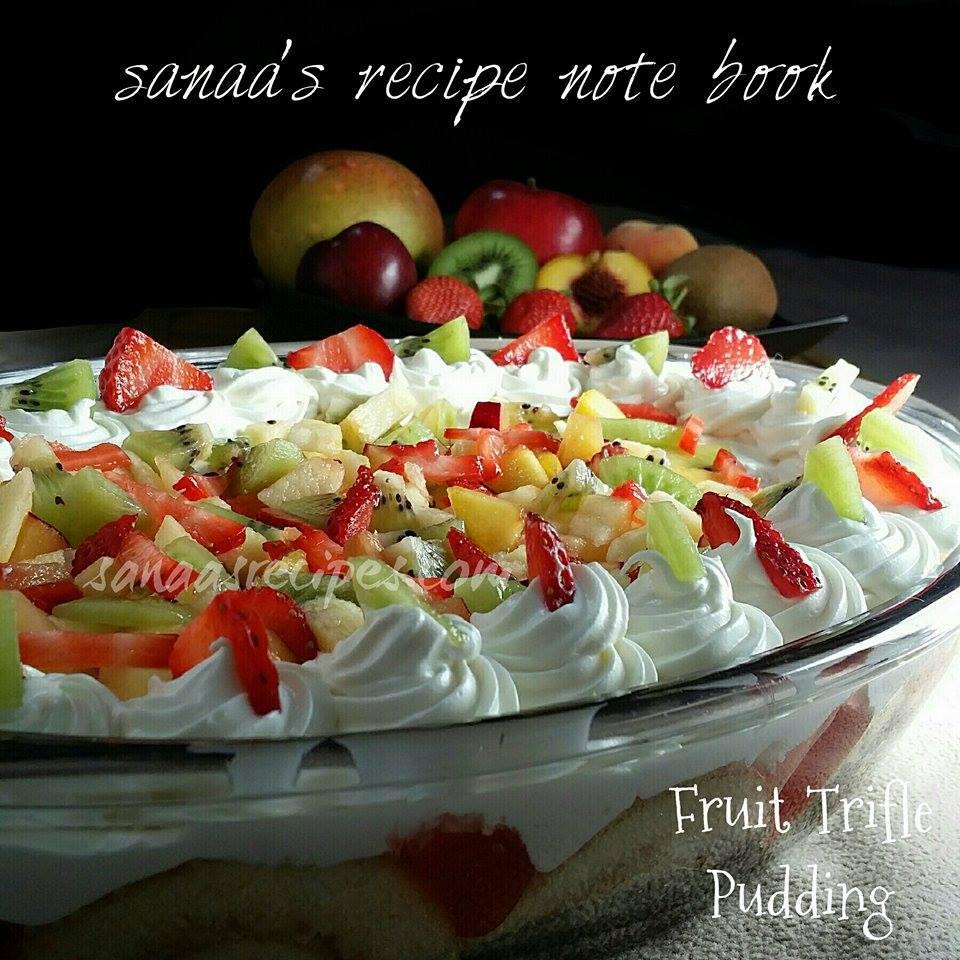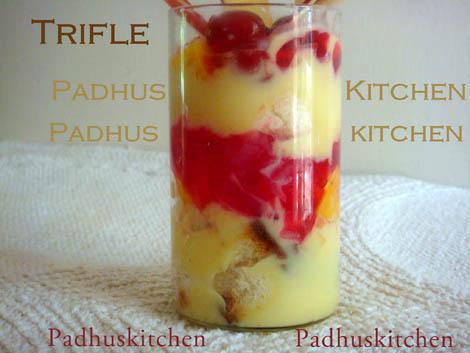The first image is the image on the left, the second image is the image on the right. Examine the images to the left and right. Is the description "The image to the right is in a cup instead of a bowl." accurate? Answer yes or no. Yes. 